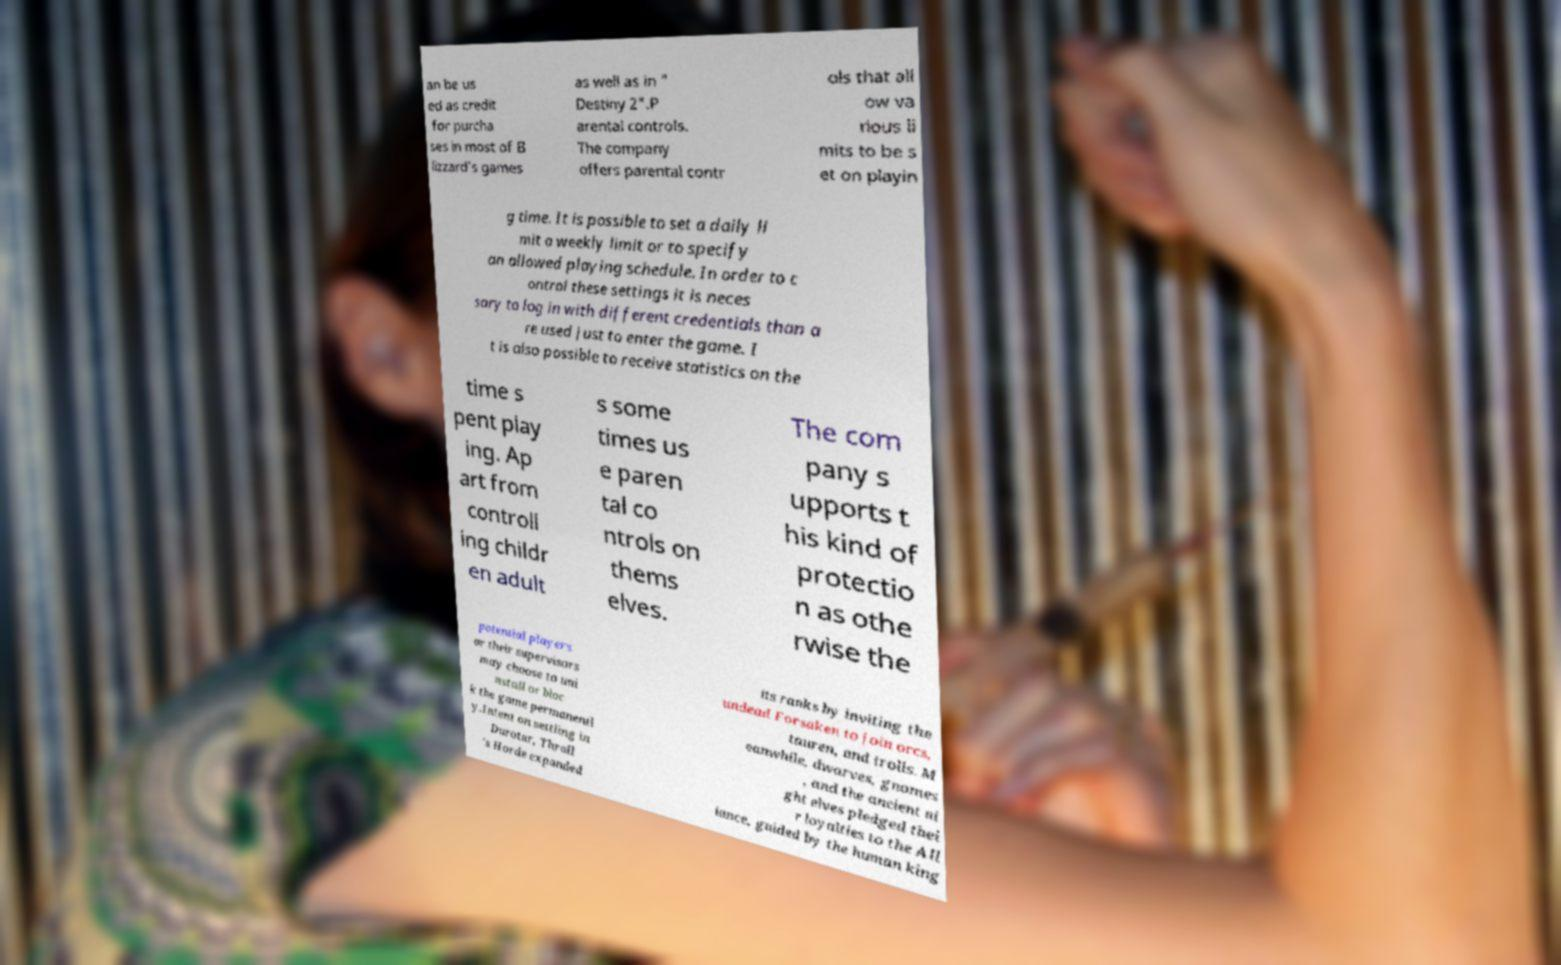Can you accurately transcribe the text from the provided image for me? an be us ed as credit for purcha ses in most of B lizzard's games as well as in " Destiny 2".P arental controls. The company offers parental contr ols that all ow va rious li mits to be s et on playin g time. It is possible to set a daily li mit a weekly limit or to specify an allowed playing schedule. In order to c ontrol these settings it is neces sary to log in with different credentials than a re used just to enter the game. I t is also possible to receive statistics on the time s pent play ing. Ap art from controll ing childr en adult s some times us e paren tal co ntrols on thems elves. The com pany s upports t his kind of protectio n as othe rwise the potential players or their supervisors may choose to uni nstall or bloc k the game permanentl y.Intent on settling in Durotar, Thrall 's Horde expanded its ranks by inviting the undead Forsaken to join orcs, tauren, and trolls. M eanwhile, dwarves, gnomes , and the ancient ni ght elves pledged thei r loyalties to the All iance, guided by the human king 